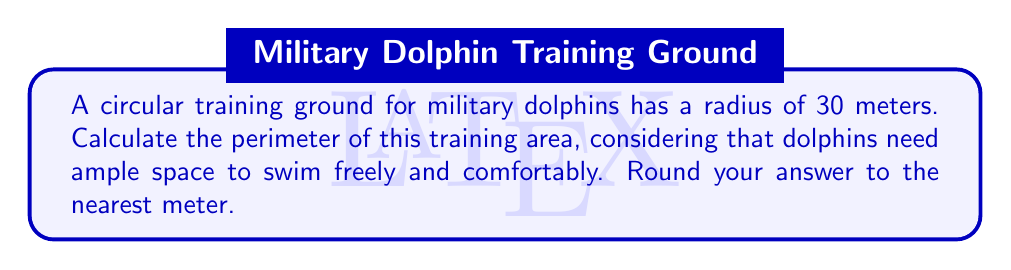What is the answer to this math problem? To find the perimeter of a circular training ground, we need to calculate its circumference. The formula for the circumference of a circle is:

$$C = 2\pi r$$

Where:
$C$ = circumference
$\pi$ = pi (approximately 3.14159)
$r$ = radius

Given:
$r = 30$ meters

Step 1: Substitute the values into the formula
$$C = 2\pi(30)$$

Step 2: Multiply
$$C = 60\pi$$

Step 3: Calculate the result
$$C \approx 60 \times 3.14159 = 188.4954$$

Step 4: Round to the nearest meter
$$C \approx 188 \text{ meters}$$

This perimeter ensures that the dolphins have a spacious environment for their training and well-being.
Answer: 188 meters 